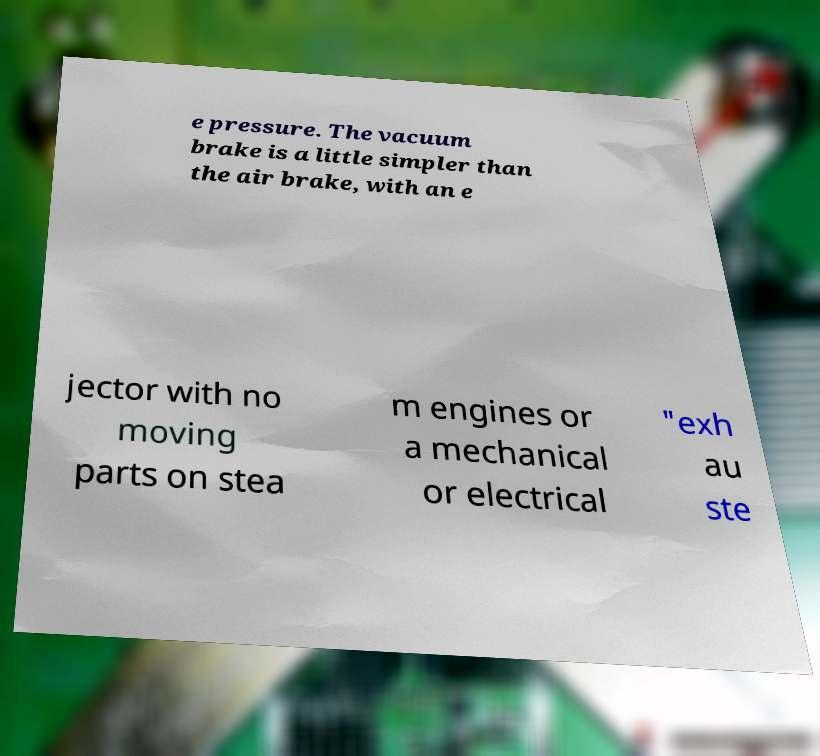Could you assist in decoding the text presented in this image and type it out clearly? e pressure. The vacuum brake is a little simpler than the air brake, with an e jector with no moving parts on stea m engines or a mechanical or electrical "exh au ste 